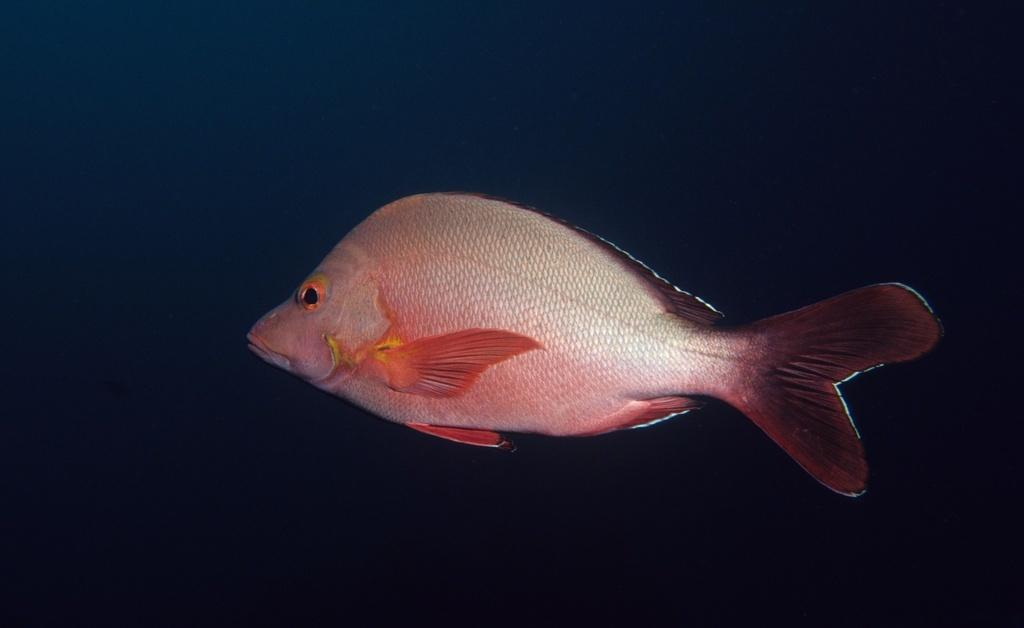What is the main subject of the image? There is a fish in the center of the image. What color is the background of the image? The background of the image is blue. What type of stick can be seen in the image? There is no stick present in the image. What color paint is used to create the fish in the image? The image does not provide information about the medium or technique used to create the fish, so it is impossible to determine the color paint used. 